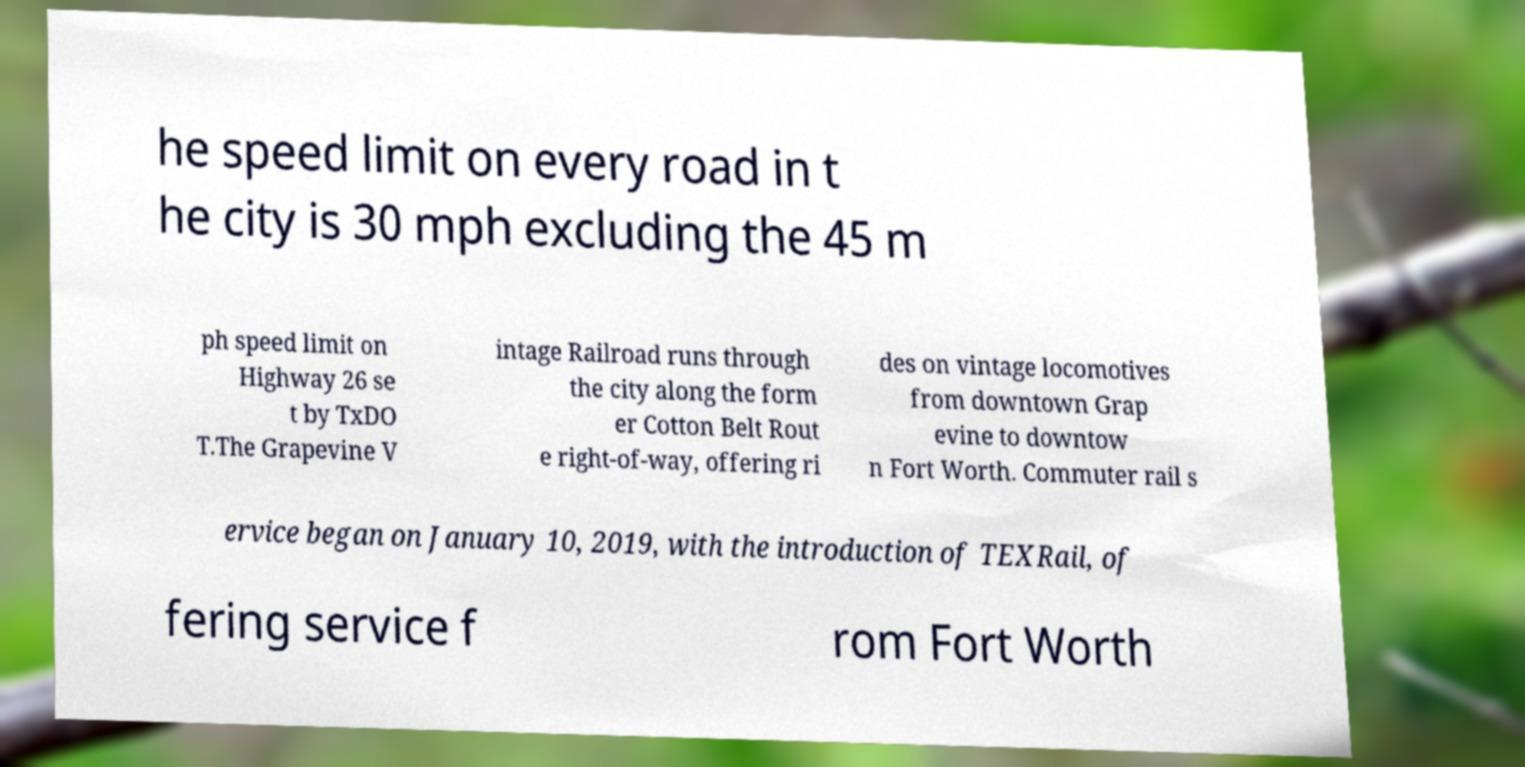For documentation purposes, I need the text within this image transcribed. Could you provide that? he speed limit on every road in t he city is 30 mph excluding the 45 m ph speed limit on Highway 26 se t by TxDO T.The Grapevine V intage Railroad runs through the city along the form er Cotton Belt Rout e right-of-way, offering ri des on vintage locomotives from downtown Grap evine to downtow n Fort Worth. Commuter rail s ervice began on January 10, 2019, with the introduction of TEXRail, of fering service f rom Fort Worth 